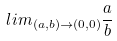<formula> <loc_0><loc_0><loc_500><loc_500>l i m _ { ( a , b ) \rightarrow ( 0 , 0 ) } \frac { a } { b }</formula> 